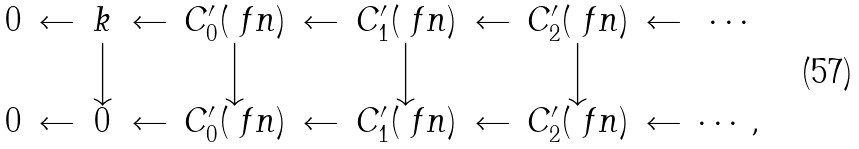<formula> <loc_0><loc_0><loc_500><loc_500>\begin{array} { c c c c c c c c c c c } 0 & \leftarrow & k & \leftarrow & C _ { 0 } ^ { \prime } ( \ f n ) & \leftarrow & C _ { 1 } ^ { \prime } ( \ f n ) & \leftarrow & C _ { 2 } ^ { \prime } ( \ f n ) & \leftarrow & \cdots \\ & & \Big \downarrow & & \Big \downarrow & & \Big \downarrow & & \Big \downarrow & \\ 0 & \leftarrow & 0 & \leftarrow & C _ { 0 } ^ { \prime } ( \ f n ) & \leftarrow & C _ { 1 } ^ { \prime } ( \ f n ) & \leftarrow & C _ { 2 } ^ { \prime } ( \ f n ) & \leftarrow & \cdots , \end{array}</formula> 